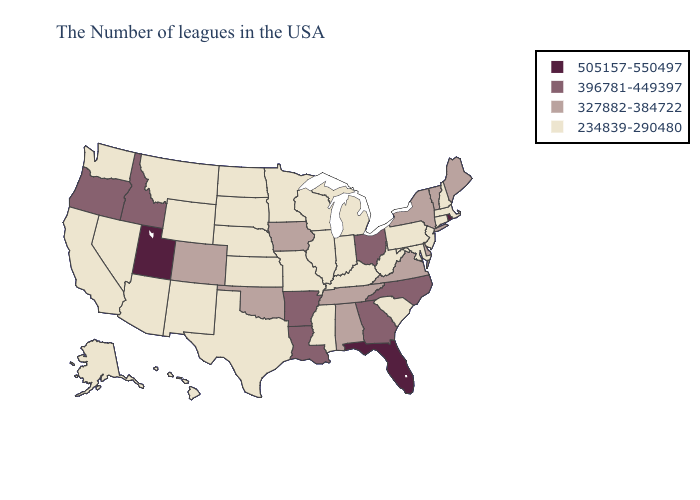Name the states that have a value in the range 396781-449397?
Keep it brief. North Carolina, Ohio, Georgia, Louisiana, Arkansas, Idaho, Oregon. What is the value of Iowa?
Short answer required. 327882-384722. What is the highest value in the MidWest ?
Keep it brief. 396781-449397. What is the highest value in the USA?
Answer briefly. 505157-550497. What is the value of Kansas?
Answer briefly. 234839-290480. Is the legend a continuous bar?
Give a very brief answer. No. What is the highest value in the West ?
Short answer required. 505157-550497. What is the lowest value in the USA?
Short answer required. 234839-290480. How many symbols are there in the legend?
Quick response, please. 4. Name the states that have a value in the range 396781-449397?
Short answer required. North Carolina, Ohio, Georgia, Louisiana, Arkansas, Idaho, Oregon. What is the value of Wyoming?
Be succinct. 234839-290480. What is the lowest value in the USA?
Concise answer only. 234839-290480. Name the states that have a value in the range 396781-449397?
Answer briefly. North Carolina, Ohio, Georgia, Louisiana, Arkansas, Idaho, Oregon. Name the states that have a value in the range 234839-290480?
Be succinct. Massachusetts, New Hampshire, Connecticut, New Jersey, Maryland, Pennsylvania, South Carolina, West Virginia, Michigan, Kentucky, Indiana, Wisconsin, Illinois, Mississippi, Missouri, Minnesota, Kansas, Nebraska, Texas, South Dakota, North Dakota, Wyoming, New Mexico, Montana, Arizona, Nevada, California, Washington, Alaska, Hawaii. Which states hav the highest value in the Northeast?
Write a very short answer. Rhode Island. 